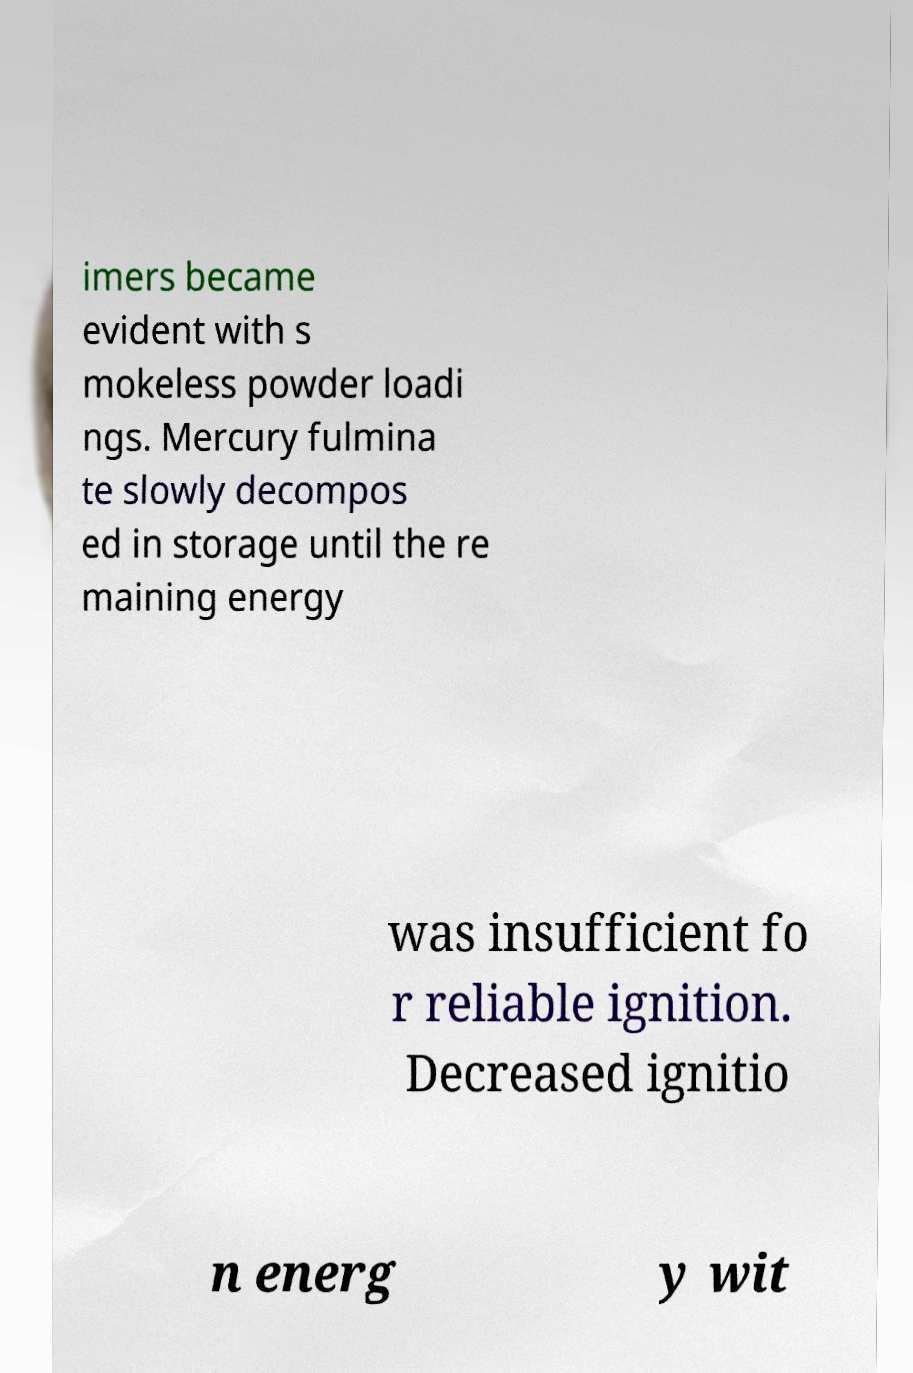Can you accurately transcribe the text from the provided image for me? imers became evident with s mokeless powder loadi ngs. Mercury fulmina te slowly decompos ed in storage until the re maining energy was insufficient fo r reliable ignition. Decreased ignitio n energ y wit 